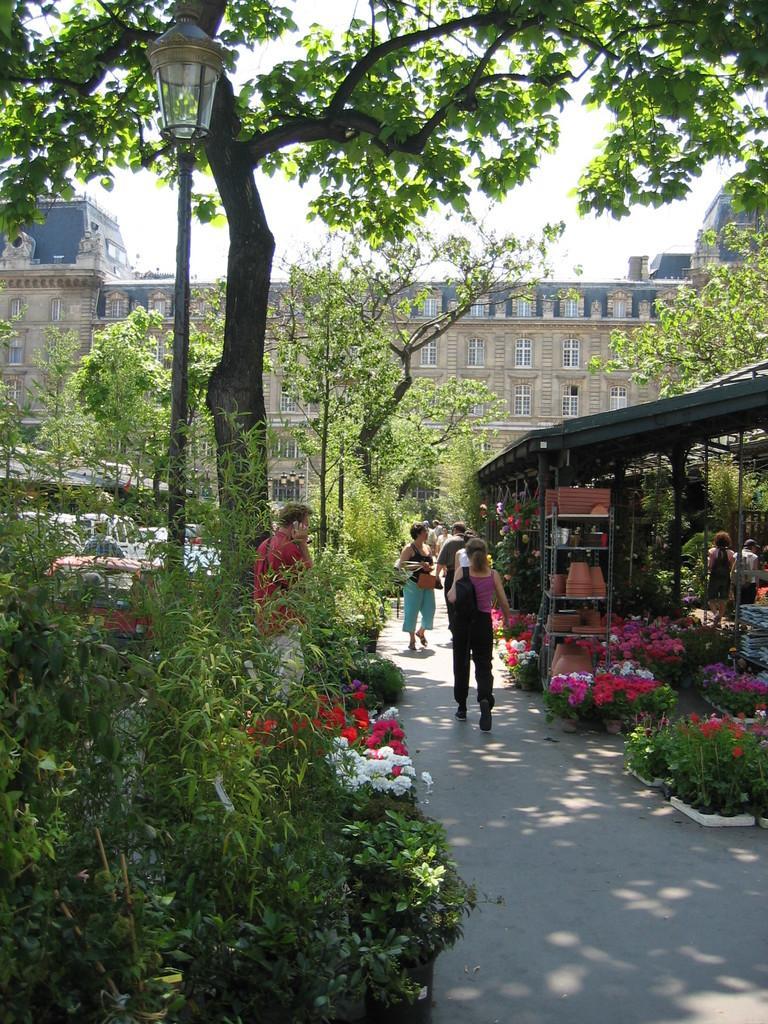How would you summarize this image in a sentence or two? In the background we can see the sky. In this picture we can see a building, trees, plants, pots, flowers, shed, pathway, objects and people. On the right side of the picture we can see pots arranged in the racks. 